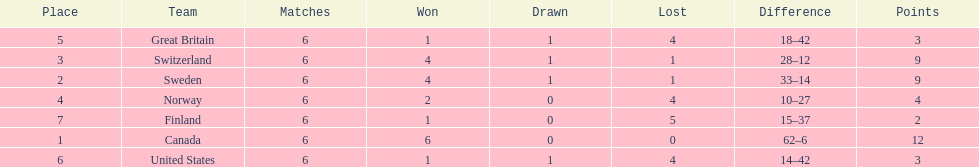How many teams won 6 matches? 1. 